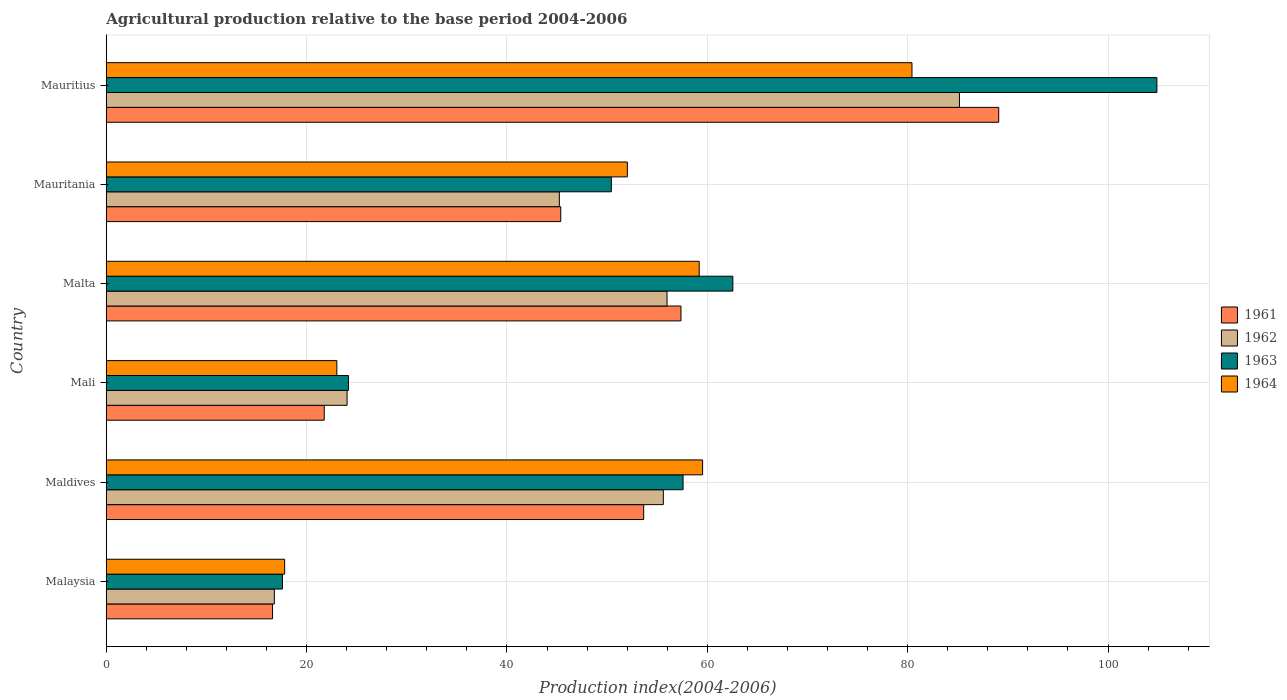How many different coloured bars are there?
Keep it short and to the point. 4. Are the number of bars per tick equal to the number of legend labels?
Provide a succinct answer. Yes. Are the number of bars on each tick of the Y-axis equal?
Your answer should be compact. Yes. What is the label of the 5th group of bars from the top?
Offer a terse response. Maldives. Across all countries, what is the maximum agricultural production index in 1961?
Offer a terse response. 89.09. In which country was the agricultural production index in 1964 maximum?
Your response must be concise. Mauritius. In which country was the agricultural production index in 1961 minimum?
Give a very brief answer. Malaysia. What is the total agricultural production index in 1962 in the graph?
Give a very brief answer. 282.81. What is the difference between the agricultural production index in 1962 in Maldives and that in Malta?
Your answer should be very brief. -0.37. What is the difference between the agricultural production index in 1962 in Maldives and the agricultural production index in 1963 in Mali?
Offer a terse response. 31.43. What is the average agricultural production index in 1963 per country?
Offer a very short reply. 52.87. What is the difference between the agricultural production index in 1961 and agricultural production index in 1964 in Mauritania?
Your answer should be compact. -6.65. What is the ratio of the agricultural production index in 1961 in Malaysia to that in Mauritania?
Make the answer very short. 0.37. Is the agricultural production index in 1964 in Mali less than that in Mauritius?
Offer a terse response. Yes. What is the difference between the highest and the second highest agricultural production index in 1962?
Keep it short and to the point. 29.19. What is the difference between the highest and the lowest agricultural production index in 1962?
Offer a very short reply. 68.39. What does the 1st bar from the top in Mauritius represents?
Offer a very short reply. 1964. What does the 2nd bar from the bottom in Malta represents?
Make the answer very short. 1962. How many countries are there in the graph?
Offer a very short reply. 6. What is the difference between two consecutive major ticks on the X-axis?
Keep it short and to the point. 20. Are the values on the major ticks of X-axis written in scientific E-notation?
Keep it short and to the point. No. Does the graph contain any zero values?
Your answer should be compact. No. Where does the legend appear in the graph?
Offer a very short reply. Center right. How many legend labels are there?
Your answer should be compact. 4. How are the legend labels stacked?
Provide a succinct answer. Vertical. What is the title of the graph?
Provide a short and direct response. Agricultural production relative to the base period 2004-2006. Does "1998" appear as one of the legend labels in the graph?
Keep it short and to the point. No. What is the label or title of the X-axis?
Your response must be concise. Production index(2004-2006). What is the label or title of the Y-axis?
Ensure brevity in your answer.  Country. What is the Production index(2004-2006) in 1961 in Malaysia?
Give a very brief answer. 16.6. What is the Production index(2004-2006) in 1962 in Malaysia?
Offer a very short reply. 16.78. What is the Production index(2004-2006) of 1963 in Malaysia?
Provide a succinct answer. 17.59. What is the Production index(2004-2006) of 1964 in Malaysia?
Provide a succinct answer. 17.81. What is the Production index(2004-2006) of 1961 in Maldives?
Your response must be concise. 53.65. What is the Production index(2004-2006) of 1962 in Maldives?
Ensure brevity in your answer.  55.61. What is the Production index(2004-2006) of 1963 in Maldives?
Give a very brief answer. 57.58. What is the Production index(2004-2006) of 1964 in Maldives?
Ensure brevity in your answer.  59.53. What is the Production index(2004-2006) of 1961 in Mali?
Offer a terse response. 21.76. What is the Production index(2004-2006) of 1962 in Mali?
Ensure brevity in your answer.  24.04. What is the Production index(2004-2006) in 1963 in Mali?
Provide a short and direct response. 24.18. What is the Production index(2004-2006) of 1964 in Mali?
Give a very brief answer. 23.02. What is the Production index(2004-2006) of 1961 in Malta?
Your response must be concise. 57.37. What is the Production index(2004-2006) of 1962 in Malta?
Your answer should be compact. 55.98. What is the Production index(2004-2006) in 1963 in Malta?
Provide a succinct answer. 62.55. What is the Production index(2004-2006) of 1964 in Malta?
Provide a short and direct response. 59.19. What is the Production index(2004-2006) of 1961 in Mauritania?
Your answer should be compact. 45.37. What is the Production index(2004-2006) in 1962 in Mauritania?
Make the answer very short. 45.23. What is the Production index(2004-2006) in 1963 in Mauritania?
Offer a terse response. 50.42. What is the Production index(2004-2006) in 1964 in Mauritania?
Your answer should be compact. 52.02. What is the Production index(2004-2006) in 1961 in Mauritius?
Your response must be concise. 89.09. What is the Production index(2004-2006) of 1962 in Mauritius?
Provide a succinct answer. 85.17. What is the Production index(2004-2006) in 1963 in Mauritius?
Offer a very short reply. 104.88. What is the Production index(2004-2006) in 1964 in Mauritius?
Provide a short and direct response. 80.43. Across all countries, what is the maximum Production index(2004-2006) in 1961?
Provide a short and direct response. 89.09. Across all countries, what is the maximum Production index(2004-2006) in 1962?
Ensure brevity in your answer.  85.17. Across all countries, what is the maximum Production index(2004-2006) of 1963?
Offer a terse response. 104.88. Across all countries, what is the maximum Production index(2004-2006) of 1964?
Your answer should be very brief. 80.43. Across all countries, what is the minimum Production index(2004-2006) of 1961?
Your answer should be very brief. 16.6. Across all countries, what is the minimum Production index(2004-2006) in 1962?
Provide a short and direct response. 16.78. Across all countries, what is the minimum Production index(2004-2006) in 1963?
Make the answer very short. 17.59. Across all countries, what is the minimum Production index(2004-2006) in 1964?
Your answer should be very brief. 17.81. What is the total Production index(2004-2006) in 1961 in the graph?
Provide a succinct answer. 283.84. What is the total Production index(2004-2006) of 1962 in the graph?
Keep it short and to the point. 282.81. What is the total Production index(2004-2006) of 1963 in the graph?
Keep it short and to the point. 317.2. What is the total Production index(2004-2006) in 1964 in the graph?
Provide a succinct answer. 292. What is the difference between the Production index(2004-2006) of 1961 in Malaysia and that in Maldives?
Make the answer very short. -37.05. What is the difference between the Production index(2004-2006) in 1962 in Malaysia and that in Maldives?
Ensure brevity in your answer.  -38.83. What is the difference between the Production index(2004-2006) in 1963 in Malaysia and that in Maldives?
Provide a short and direct response. -39.99. What is the difference between the Production index(2004-2006) of 1964 in Malaysia and that in Maldives?
Offer a terse response. -41.72. What is the difference between the Production index(2004-2006) of 1961 in Malaysia and that in Mali?
Provide a short and direct response. -5.16. What is the difference between the Production index(2004-2006) in 1962 in Malaysia and that in Mali?
Give a very brief answer. -7.26. What is the difference between the Production index(2004-2006) of 1963 in Malaysia and that in Mali?
Your response must be concise. -6.59. What is the difference between the Production index(2004-2006) in 1964 in Malaysia and that in Mali?
Your response must be concise. -5.21. What is the difference between the Production index(2004-2006) of 1961 in Malaysia and that in Malta?
Ensure brevity in your answer.  -40.77. What is the difference between the Production index(2004-2006) in 1962 in Malaysia and that in Malta?
Provide a succinct answer. -39.2. What is the difference between the Production index(2004-2006) of 1963 in Malaysia and that in Malta?
Make the answer very short. -44.96. What is the difference between the Production index(2004-2006) of 1964 in Malaysia and that in Malta?
Make the answer very short. -41.38. What is the difference between the Production index(2004-2006) in 1961 in Malaysia and that in Mauritania?
Provide a succinct answer. -28.77. What is the difference between the Production index(2004-2006) of 1962 in Malaysia and that in Mauritania?
Give a very brief answer. -28.45. What is the difference between the Production index(2004-2006) in 1963 in Malaysia and that in Mauritania?
Give a very brief answer. -32.83. What is the difference between the Production index(2004-2006) of 1964 in Malaysia and that in Mauritania?
Make the answer very short. -34.21. What is the difference between the Production index(2004-2006) in 1961 in Malaysia and that in Mauritius?
Offer a terse response. -72.49. What is the difference between the Production index(2004-2006) of 1962 in Malaysia and that in Mauritius?
Ensure brevity in your answer.  -68.39. What is the difference between the Production index(2004-2006) of 1963 in Malaysia and that in Mauritius?
Your answer should be very brief. -87.29. What is the difference between the Production index(2004-2006) in 1964 in Malaysia and that in Mauritius?
Provide a succinct answer. -62.62. What is the difference between the Production index(2004-2006) in 1961 in Maldives and that in Mali?
Ensure brevity in your answer.  31.89. What is the difference between the Production index(2004-2006) in 1962 in Maldives and that in Mali?
Offer a very short reply. 31.57. What is the difference between the Production index(2004-2006) of 1963 in Maldives and that in Mali?
Your answer should be very brief. 33.4. What is the difference between the Production index(2004-2006) of 1964 in Maldives and that in Mali?
Your response must be concise. 36.51. What is the difference between the Production index(2004-2006) in 1961 in Maldives and that in Malta?
Make the answer very short. -3.72. What is the difference between the Production index(2004-2006) in 1962 in Maldives and that in Malta?
Your response must be concise. -0.37. What is the difference between the Production index(2004-2006) in 1963 in Maldives and that in Malta?
Your response must be concise. -4.97. What is the difference between the Production index(2004-2006) of 1964 in Maldives and that in Malta?
Your answer should be compact. 0.34. What is the difference between the Production index(2004-2006) of 1961 in Maldives and that in Mauritania?
Keep it short and to the point. 8.28. What is the difference between the Production index(2004-2006) in 1962 in Maldives and that in Mauritania?
Give a very brief answer. 10.38. What is the difference between the Production index(2004-2006) in 1963 in Maldives and that in Mauritania?
Keep it short and to the point. 7.16. What is the difference between the Production index(2004-2006) in 1964 in Maldives and that in Mauritania?
Your answer should be compact. 7.51. What is the difference between the Production index(2004-2006) of 1961 in Maldives and that in Mauritius?
Provide a succinct answer. -35.44. What is the difference between the Production index(2004-2006) in 1962 in Maldives and that in Mauritius?
Make the answer very short. -29.56. What is the difference between the Production index(2004-2006) of 1963 in Maldives and that in Mauritius?
Give a very brief answer. -47.3. What is the difference between the Production index(2004-2006) of 1964 in Maldives and that in Mauritius?
Ensure brevity in your answer.  -20.9. What is the difference between the Production index(2004-2006) in 1961 in Mali and that in Malta?
Provide a succinct answer. -35.61. What is the difference between the Production index(2004-2006) of 1962 in Mali and that in Malta?
Offer a very short reply. -31.94. What is the difference between the Production index(2004-2006) in 1963 in Mali and that in Malta?
Your response must be concise. -38.37. What is the difference between the Production index(2004-2006) in 1964 in Mali and that in Malta?
Offer a very short reply. -36.17. What is the difference between the Production index(2004-2006) of 1961 in Mali and that in Mauritania?
Your response must be concise. -23.61. What is the difference between the Production index(2004-2006) of 1962 in Mali and that in Mauritania?
Offer a terse response. -21.19. What is the difference between the Production index(2004-2006) of 1963 in Mali and that in Mauritania?
Offer a terse response. -26.24. What is the difference between the Production index(2004-2006) of 1961 in Mali and that in Mauritius?
Ensure brevity in your answer.  -67.33. What is the difference between the Production index(2004-2006) in 1962 in Mali and that in Mauritius?
Provide a short and direct response. -61.13. What is the difference between the Production index(2004-2006) in 1963 in Mali and that in Mauritius?
Your response must be concise. -80.7. What is the difference between the Production index(2004-2006) in 1964 in Mali and that in Mauritius?
Your answer should be very brief. -57.41. What is the difference between the Production index(2004-2006) of 1962 in Malta and that in Mauritania?
Offer a very short reply. 10.75. What is the difference between the Production index(2004-2006) of 1963 in Malta and that in Mauritania?
Your answer should be very brief. 12.13. What is the difference between the Production index(2004-2006) in 1964 in Malta and that in Mauritania?
Offer a very short reply. 7.17. What is the difference between the Production index(2004-2006) of 1961 in Malta and that in Mauritius?
Your answer should be very brief. -31.72. What is the difference between the Production index(2004-2006) in 1962 in Malta and that in Mauritius?
Your response must be concise. -29.19. What is the difference between the Production index(2004-2006) in 1963 in Malta and that in Mauritius?
Your response must be concise. -42.33. What is the difference between the Production index(2004-2006) in 1964 in Malta and that in Mauritius?
Provide a succinct answer. -21.24. What is the difference between the Production index(2004-2006) of 1961 in Mauritania and that in Mauritius?
Your response must be concise. -43.72. What is the difference between the Production index(2004-2006) of 1962 in Mauritania and that in Mauritius?
Offer a terse response. -39.94. What is the difference between the Production index(2004-2006) in 1963 in Mauritania and that in Mauritius?
Your response must be concise. -54.46. What is the difference between the Production index(2004-2006) of 1964 in Mauritania and that in Mauritius?
Keep it short and to the point. -28.41. What is the difference between the Production index(2004-2006) of 1961 in Malaysia and the Production index(2004-2006) of 1962 in Maldives?
Provide a succinct answer. -39.01. What is the difference between the Production index(2004-2006) of 1961 in Malaysia and the Production index(2004-2006) of 1963 in Maldives?
Your answer should be compact. -40.98. What is the difference between the Production index(2004-2006) of 1961 in Malaysia and the Production index(2004-2006) of 1964 in Maldives?
Your answer should be very brief. -42.93. What is the difference between the Production index(2004-2006) in 1962 in Malaysia and the Production index(2004-2006) in 1963 in Maldives?
Keep it short and to the point. -40.8. What is the difference between the Production index(2004-2006) of 1962 in Malaysia and the Production index(2004-2006) of 1964 in Maldives?
Your response must be concise. -42.75. What is the difference between the Production index(2004-2006) in 1963 in Malaysia and the Production index(2004-2006) in 1964 in Maldives?
Keep it short and to the point. -41.94. What is the difference between the Production index(2004-2006) in 1961 in Malaysia and the Production index(2004-2006) in 1962 in Mali?
Your response must be concise. -7.44. What is the difference between the Production index(2004-2006) in 1961 in Malaysia and the Production index(2004-2006) in 1963 in Mali?
Ensure brevity in your answer.  -7.58. What is the difference between the Production index(2004-2006) of 1961 in Malaysia and the Production index(2004-2006) of 1964 in Mali?
Provide a short and direct response. -6.42. What is the difference between the Production index(2004-2006) of 1962 in Malaysia and the Production index(2004-2006) of 1963 in Mali?
Provide a succinct answer. -7.4. What is the difference between the Production index(2004-2006) of 1962 in Malaysia and the Production index(2004-2006) of 1964 in Mali?
Offer a very short reply. -6.24. What is the difference between the Production index(2004-2006) of 1963 in Malaysia and the Production index(2004-2006) of 1964 in Mali?
Offer a very short reply. -5.43. What is the difference between the Production index(2004-2006) of 1961 in Malaysia and the Production index(2004-2006) of 1962 in Malta?
Provide a short and direct response. -39.38. What is the difference between the Production index(2004-2006) in 1961 in Malaysia and the Production index(2004-2006) in 1963 in Malta?
Your answer should be compact. -45.95. What is the difference between the Production index(2004-2006) of 1961 in Malaysia and the Production index(2004-2006) of 1964 in Malta?
Offer a very short reply. -42.59. What is the difference between the Production index(2004-2006) in 1962 in Malaysia and the Production index(2004-2006) in 1963 in Malta?
Ensure brevity in your answer.  -45.77. What is the difference between the Production index(2004-2006) of 1962 in Malaysia and the Production index(2004-2006) of 1964 in Malta?
Offer a very short reply. -42.41. What is the difference between the Production index(2004-2006) in 1963 in Malaysia and the Production index(2004-2006) in 1964 in Malta?
Provide a short and direct response. -41.6. What is the difference between the Production index(2004-2006) in 1961 in Malaysia and the Production index(2004-2006) in 1962 in Mauritania?
Make the answer very short. -28.63. What is the difference between the Production index(2004-2006) of 1961 in Malaysia and the Production index(2004-2006) of 1963 in Mauritania?
Provide a succinct answer. -33.82. What is the difference between the Production index(2004-2006) in 1961 in Malaysia and the Production index(2004-2006) in 1964 in Mauritania?
Offer a terse response. -35.42. What is the difference between the Production index(2004-2006) in 1962 in Malaysia and the Production index(2004-2006) in 1963 in Mauritania?
Give a very brief answer. -33.64. What is the difference between the Production index(2004-2006) in 1962 in Malaysia and the Production index(2004-2006) in 1964 in Mauritania?
Your answer should be compact. -35.24. What is the difference between the Production index(2004-2006) of 1963 in Malaysia and the Production index(2004-2006) of 1964 in Mauritania?
Offer a terse response. -34.43. What is the difference between the Production index(2004-2006) in 1961 in Malaysia and the Production index(2004-2006) in 1962 in Mauritius?
Your answer should be compact. -68.57. What is the difference between the Production index(2004-2006) in 1961 in Malaysia and the Production index(2004-2006) in 1963 in Mauritius?
Your answer should be very brief. -88.28. What is the difference between the Production index(2004-2006) in 1961 in Malaysia and the Production index(2004-2006) in 1964 in Mauritius?
Ensure brevity in your answer.  -63.83. What is the difference between the Production index(2004-2006) of 1962 in Malaysia and the Production index(2004-2006) of 1963 in Mauritius?
Offer a terse response. -88.1. What is the difference between the Production index(2004-2006) of 1962 in Malaysia and the Production index(2004-2006) of 1964 in Mauritius?
Provide a short and direct response. -63.65. What is the difference between the Production index(2004-2006) of 1963 in Malaysia and the Production index(2004-2006) of 1964 in Mauritius?
Give a very brief answer. -62.84. What is the difference between the Production index(2004-2006) in 1961 in Maldives and the Production index(2004-2006) in 1962 in Mali?
Provide a succinct answer. 29.61. What is the difference between the Production index(2004-2006) of 1961 in Maldives and the Production index(2004-2006) of 1963 in Mali?
Provide a short and direct response. 29.47. What is the difference between the Production index(2004-2006) in 1961 in Maldives and the Production index(2004-2006) in 1964 in Mali?
Keep it short and to the point. 30.63. What is the difference between the Production index(2004-2006) in 1962 in Maldives and the Production index(2004-2006) in 1963 in Mali?
Provide a short and direct response. 31.43. What is the difference between the Production index(2004-2006) in 1962 in Maldives and the Production index(2004-2006) in 1964 in Mali?
Your response must be concise. 32.59. What is the difference between the Production index(2004-2006) in 1963 in Maldives and the Production index(2004-2006) in 1964 in Mali?
Ensure brevity in your answer.  34.56. What is the difference between the Production index(2004-2006) in 1961 in Maldives and the Production index(2004-2006) in 1962 in Malta?
Keep it short and to the point. -2.33. What is the difference between the Production index(2004-2006) in 1961 in Maldives and the Production index(2004-2006) in 1963 in Malta?
Make the answer very short. -8.9. What is the difference between the Production index(2004-2006) of 1961 in Maldives and the Production index(2004-2006) of 1964 in Malta?
Your answer should be compact. -5.54. What is the difference between the Production index(2004-2006) in 1962 in Maldives and the Production index(2004-2006) in 1963 in Malta?
Your response must be concise. -6.94. What is the difference between the Production index(2004-2006) of 1962 in Maldives and the Production index(2004-2006) of 1964 in Malta?
Give a very brief answer. -3.58. What is the difference between the Production index(2004-2006) of 1963 in Maldives and the Production index(2004-2006) of 1964 in Malta?
Make the answer very short. -1.61. What is the difference between the Production index(2004-2006) in 1961 in Maldives and the Production index(2004-2006) in 1962 in Mauritania?
Provide a succinct answer. 8.42. What is the difference between the Production index(2004-2006) in 1961 in Maldives and the Production index(2004-2006) in 1963 in Mauritania?
Offer a very short reply. 3.23. What is the difference between the Production index(2004-2006) in 1961 in Maldives and the Production index(2004-2006) in 1964 in Mauritania?
Give a very brief answer. 1.63. What is the difference between the Production index(2004-2006) in 1962 in Maldives and the Production index(2004-2006) in 1963 in Mauritania?
Make the answer very short. 5.19. What is the difference between the Production index(2004-2006) of 1962 in Maldives and the Production index(2004-2006) of 1964 in Mauritania?
Provide a short and direct response. 3.59. What is the difference between the Production index(2004-2006) in 1963 in Maldives and the Production index(2004-2006) in 1964 in Mauritania?
Offer a terse response. 5.56. What is the difference between the Production index(2004-2006) of 1961 in Maldives and the Production index(2004-2006) of 1962 in Mauritius?
Offer a very short reply. -31.52. What is the difference between the Production index(2004-2006) in 1961 in Maldives and the Production index(2004-2006) in 1963 in Mauritius?
Your response must be concise. -51.23. What is the difference between the Production index(2004-2006) in 1961 in Maldives and the Production index(2004-2006) in 1964 in Mauritius?
Your response must be concise. -26.78. What is the difference between the Production index(2004-2006) in 1962 in Maldives and the Production index(2004-2006) in 1963 in Mauritius?
Offer a very short reply. -49.27. What is the difference between the Production index(2004-2006) in 1962 in Maldives and the Production index(2004-2006) in 1964 in Mauritius?
Keep it short and to the point. -24.82. What is the difference between the Production index(2004-2006) of 1963 in Maldives and the Production index(2004-2006) of 1964 in Mauritius?
Your answer should be compact. -22.85. What is the difference between the Production index(2004-2006) in 1961 in Mali and the Production index(2004-2006) in 1962 in Malta?
Your answer should be very brief. -34.22. What is the difference between the Production index(2004-2006) of 1961 in Mali and the Production index(2004-2006) of 1963 in Malta?
Make the answer very short. -40.79. What is the difference between the Production index(2004-2006) of 1961 in Mali and the Production index(2004-2006) of 1964 in Malta?
Give a very brief answer. -37.43. What is the difference between the Production index(2004-2006) of 1962 in Mali and the Production index(2004-2006) of 1963 in Malta?
Offer a very short reply. -38.51. What is the difference between the Production index(2004-2006) of 1962 in Mali and the Production index(2004-2006) of 1964 in Malta?
Ensure brevity in your answer.  -35.15. What is the difference between the Production index(2004-2006) in 1963 in Mali and the Production index(2004-2006) in 1964 in Malta?
Make the answer very short. -35.01. What is the difference between the Production index(2004-2006) of 1961 in Mali and the Production index(2004-2006) of 1962 in Mauritania?
Offer a terse response. -23.47. What is the difference between the Production index(2004-2006) in 1961 in Mali and the Production index(2004-2006) in 1963 in Mauritania?
Offer a terse response. -28.66. What is the difference between the Production index(2004-2006) in 1961 in Mali and the Production index(2004-2006) in 1964 in Mauritania?
Provide a short and direct response. -30.26. What is the difference between the Production index(2004-2006) in 1962 in Mali and the Production index(2004-2006) in 1963 in Mauritania?
Offer a terse response. -26.38. What is the difference between the Production index(2004-2006) in 1962 in Mali and the Production index(2004-2006) in 1964 in Mauritania?
Offer a very short reply. -27.98. What is the difference between the Production index(2004-2006) of 1963 in Mali and the Production index(2004-2006) of 1964 in Mauritania?
Make the answer very short. -27.84. What is the difference between the Production index(2004-2006) of 1961 in Mali and the Production index(2004-2006) of 1962 in Mauritius?
Your answer should be compact. -63.41. What is the difference between the Production index(2004-2006) of 1961 in Mali and the Production index(2004-2006) of 1963 in Mauritius?
Your answer should be very brief. -83.12. What is the difference between the Production index(2004-2006) of 1961 in Mali and the Production index(2004-2006) of 1964 in Mauritius?
Offer a very short reply. -58.67. What is the difference between the Production index(2004-2006) of 1962 in Mali and the Production index(2004-2006) of 1963 in Mauritius?
Keep it short and to the point. -80.84. What is the difference between the Production index(2004-2006) in 1962 in Mali and the Production index(2004-2006) in 1964 in Mauritius?
Provide a succinct answer. -56.39. What is the difference between the Production index(2004-2006) of 1963 in Mali and the Production index(2004-2006) of 1964 in Mauritius?
Ensure brevity in your answer.  -56.25. What is the difference between the Production index(2004-2006) in 1961 in Malta and the Production index(2004-2006) in 1962 in Mauritania?
Offer a very short reply. 12.14. What is the difference between the Production index(2004-2006) of 1961 in Malta and the Production index(2004-2006) of 1963 in Mauritania?
Give a very brief answer. 6.95. What is the difference between the Production index(2004-2006) in 1961 in Malta and the Production index(2004-2006) in 1964 in Mauritania?
Offer a terse response. 5.35. What is the difference between the Production index(2004-2006) in 1962 in Malta and the Production index(2004-2006) in 1963 in Mauritania?
Your response must be concise. 5.56. What is the difference between the Production index(2004-2006) of 1962 in Malta and the Production index(2004-2006) of 1964 in Mauritania?
Give a very brief answer. 3.96. What is the difference between the Production index(2004-2006) of 1963 in Malta and the Production index(2004-2006) of 1964 in Mauritania?
Offer a very short reply. 10.53. What is the difference between the Production index(2004-2006) in 1961 in Malta and the Production index(2004-2006) in 1962 in Mauritius?
Provide a succinct answer. -27.8. What is the difference between the Production index(2004-2006) of 1961 in Malta and the Production index(2004-2006) of 1963 in Mauritius?
Offer a terse response. -47.51. What is the difference between the Production index(2004-2006) in 1961 in Malta and the Production index(2004-2006) in 1964 in Mauritius?
Your answer should be very brief. -23.06. What is the difference between the Production index(2004-2006) in 1962 in Malta and the Production index(2004-2006) in 1963 in Mauritius?
Offer a terse response. -48.9. What is the difference between the Production index(2004-2006) in 1962 in Malta and the Production index(2004-2006) in 1964 in Mauritius?
Give a very brief answer. -24.45. What is the difference between the Production index(2004-2006) in 1963 in Malta and the Production index(2004-2006) in 1964 in Mauritius?
Keep it short and to the point. -17.88. What is the difference between the Production index(2004-2006) of 1961 in Mauritania and the Production index(2004-2006) of 1962 in Mauritius?
Offer a terse response. -39.8. What is the difference between the Production index(2004-2006) in 1961 in Mauritania and the Production index(2004-2006) in 1963 in Mauritius?
Make the answer very short. -59.51. What is the difference between the Production index(2004-2006) in 1961 in Mauritania and the Production index(2004-2006) in 1964 in Mauritius?
Provide a succinct answer. -35.06. What is the difference between the Production index(2004-2006) in 1962 in Mauritania and the Production index(2004-2006) in 1963 in Mauritius?
Ensure brevity in your answer.  -59.65. What is the difference between the Production index(2004-2006) in 1962 in Mauritania and the Production index(2004-2006) in 1964 in Mauritius?
Offer a terse response. -35.2. What is the difference between the Production index(2004-2006) in 1963 in Mauritania and the Production index(2004-2006) in 1964 in Mauritius?
Your response must be concise. -30.01. What is the average Production index(2004-2006) of 1961 per country?
Give a very brief answer. 47.31. What is the average Production index(2004-2006) of 1962 per country?
Provide a short and direct response. 47.13. What is the average Production index(2004-2006) of 1963 per country?
Offer a terse response. 52.87. What is the average Production index(2004-2006) of 1964 per country?
Provide a succinct answer. 48.67. What is the difference between the Production index(2004-2006) in 1961 and Production index(2004-2006) in 1962 in Malaysia?
Your answer should be very brief. -0.18. What is the difference between the Production index(2004-2006) of 1961 and Production index(2004-2006) of 1963 in Malaysia?
Ensure brevity in your answer.  -0.99. What is the difference between the Production index(2004-2006) in 1961 and Production index(2004-2006) in 1964 in Malaysia?
Provide a succinct answer. -1.21. What is the difference between the Production index(2004-2006) of 1962 and Production index(2004-2006) of 1963 in Malaysia?
Ensure brevity in your answer.  -0.81. What is the difference between the Production index(2004-2006) of 1962 and Production index(2004-2006) of 1964 in Malaysia?
Offer a terse response. -1.03. What is the difference between the Production index(2004-2006) in 1963 and Production index(2004-2006) in 1964 in Malaysia?
Offer a very short reply. -0.22. What is the difference between the Production index(2004-2006) of 1961 and Production index(2004-2006) of 1962 in Maldives?
Give a very brief answer. -1.96. What is the difference between the Production index(2004-2006) in 1961 and Production index(2004-2006) in 1963 in Maldives?
Provide a short and direct response. -3.93. What is the difference between the Production index(2004-2006) in 1961 and Production index(2004-2006) in 1964 in Maldives?
Ensure brevity in your answer.  -5.88. What is the difference between the Production index(2004-2006) in 1962 and Production index(2004-2006) in 1963 in Maldives?
Make the answer very short. -1.97. What is the difference between the Production index(2004-2006) of 1962 and Production index(2004-2006) of 1964 in Maldives?
Your answer should be very brief. -3.92. What is the difference between the Production index(2004-2006) in 1963 and Production index(2004-2006) in 1964 in Maldives?
Provide a succinct answer. -1.95. What is the difference between the Production index(2004-2006) in 1961 and Production index(2004-2006) in 1962 in Mali?
Provide a succinct answer. -2.28. What is the difference between the Production index(2004-2006) in 1961 and Production index(2004-2006) in 1963 in Mali?
Make the answer very short. -2.42. What is the difference between the Production index(2004-2006) in 1961 and Production index(2004-2006) in 1964 in Mali?
Ensure brevity in your answer.  -1.26. What is the difference between the Production index(2004-2006) in 1962 and Production index(2004-2006) in 1963 in Mali?
Offer a terse response. -0.14. What is the difference between the Production index(2004-2006) in 1962 and Production index(2004-2006) in 1964 in Mali?
Your answer should be very brief. 1.02. What is the difference between the Production index(2004-2006) of 1963 and Production index(2004-2006) of 1964 in Mali?
Ensure brevity in your answer.  1.16. What is the difference between the Production index(2004-2006) in 1961 and Production index(2004-2006) in 1962 in Malta?
Offer a very short reply. 1.39. What is the difference between the Production index(2004-2006) in 1961 and Production index(2004-2006) in 1963 in Malta?
Provide a succinct answer. -5.18. What is the difference between the Production index(2004-2006) in 1961 and Production index(2004-2006) in 1964 in Malta?
Offer a very short reply. -1.82. What is the difference between the Production index(2004-2006) of 1962 and Production index(2004-2006) of 1963 in Malta?
Make the answer very short. -6.57. What is the difference between the Production index(2004-2006) of 1962 and Production index(2004-2006) of 1964 in Malta?
Give a very brief answer. -3.21. What is the difference between the Production index(2004-2006) in 1963 and Production index(2004-2006) in 1964 in Malta?
Give a very brief answer. 3.36. What is the difference between the Production index(2004-2006) in 1961 and Production index(2004-2006) in 1962 in Mauritania?
Your answer should be very brief. 0.14. What is the difference between the Production index(2004-2006) of 1961 and Production index(2004-2006) of 1963 in Mauritania?
Make the answer very short. -5.05. What is the difference between the Production index(2004-2006) of 1961 and Production index(2004-2006) of 1964 in Mauritania?
Your answer should be compact. -6.65. What is the difference between the Production index(2004-2006) of 1962 and Production index(2004-2006) of 1963 in Mauritania?
Give a very brief answer. -5.19. What is the difference between the Production index(2004-2006) of 1962 and Production index(2004-2006) of 1964 in Mauritania?
Ensure brevity in your answer.  -6.79. What is the difference between the Production index(2004-2006) in 1963 and Production index(2004-2006) in 1964 in Mauritania?
Offer a terse response. -1.6. What is the difference between the Production index(2004-2006) of 1961 and Production index(2004-2006) of 1962 in Mauritius?
Your answer should be very brief. 3.92. What is the difference between the Production index(2004-2006) in 1961 and Production index(2004-2006) in 1963 in Mauritius?
Make the answer very short. -15.79. What is the difference between the Production index(2004-2006) in 1961 and Production index(2004-2006) in 1964 in Mauritius?
Offer a terse response. 8.66. What is the difference between the Production index(2004-2006) of 1962 and Production index(2004-2006) of 1963 in Mauritius?
Your answer should be compact. -19.71. What is the difference between the Production index(2004-2006) of 1962 and Production index(2004-2006) of 1964 in Mauritius?
Give a very brief answer. 4.74. What is the difference between the Production index(2004-2006) of 1963 and Production index(2004-2006) of 1964 in Mauritius?
Keep it short and to the point. 24.45. What is the ratio of the Production index(2004-2006) in 1961 in Malaysia to that in Maldives?
Keep it short and to the point. 0.31. What is the ratio of the Production index(2004-2006) of 1962 in Malaysia to that in Maldives?
Keep it short and to the point. 0.3. What is the ratio of the Production index(2004-2006) in 1963 in Malaysia to that in Maldives?
Provide a short and direct response. 0.31. What is the ratio of the Production index(2004-2006) of 1964 in Malaysia to that in Maldives?
Offer a terse response. 0.3. What is the ratio of the Production index(2004-2006) of 1961 in Malaysia to that in Mali?
Ensure brevity in your answer.  0.76. What is the ratio of the Production index(2004-2006) in 1962 in Malaysia to that in Mali?
Keep it short and to the point. 0.7. What is the ratio of the Production index(2004-2006) of 1963 in Malaysia to that in Mali?
Your response must be concise. 0.73. What is the ratio of the Production index(2004-2006) of 1964 in Malaysia to that in Mali?
Ensure brevity in your answer.  0.77. What is the ratio of the Production index(2004-2006) in 1961 in Malaysia to that in Malta?
Your answer should be very brief. 0.29. What is the ratio of the Production index(2004-2006) in 1962 in Malaysia to that in Malta?
Your response must be concise. 0.3. What is the ratio of the Production index(2004-2006) in 1963 in Malaysia to that in Malta?
Offer a terse response. 0.28. What is the ratio of the Production index(2004-2006) in 1964 in Malaysia to that in Malta?
Make the answer very short. 0.3. What is the ratio of the Production index(2004-2006) of 1961 in Malaysia to that in Mauritania?
Provide a succinct answer. 0.37. What is the ratio of the Production index(2004-2006) in 1962 in Malaysia to that in Mauritania?
Make the answer very short. 0.37. What is the ratio of the Production index(2004-2006) of 1963 in Malaysia to that in Mauritania?
Your response must be concise. 0.35. What is the ratio of the Production index(2004-2006) of 1964 in Malaysia to that in Mauritania?
Your answer should be compact. 0.34. What is the ratio of the Production index(2004-2006) of 1961 in Malaysia to that in Mauritius?
Make the answer very short. 0.19. What is the ratio of the Production index(2004-2006) in 1962 in Malaysia to that in Mauritius?
Ensure brevity in your answer.  0.2. What is the ratio of the Production index(2004-2006) in 1963 in Malaysia to that in Mauritius?
Offer a terse response. 0.17. What is the ratio of the Production index(2004-2006) of 1964 in Malaysia to that in Mauritius?
Offer a terse response. 0.22. What is the ratio of the Production index(2004-2006) of 1961 in Maldives to that in Mali?
Keep it short and to the point. 2.47. What is the ratio of the Production index(2004-2006) of 1962 in Maldives to that in Mali?
Provide a succinct answer. 2.31. What is the ratio of the Production index(2004-2006) of 1963 in Maldives to that in Mali?
Your answer should be compact. 2.38. What is the ratio of the Production index(2004-2006) in 1964 in Maldives to that in Mali?
Keep it short and to the point. 2.59. What is the ratio of the Production index(2004-2006) of 1961 in Maldives to that in Malta?
Offer a very short reply. 0.94. What is the ratio of the Production index(2004-2006) of 1962 in Maldives to that in Malta?
Give a very brief answer. 0.99. What is the ratio of the Production index(2004-2006) of 1963 in Maldives to that in Malta?
Your answer should be compact. 0.92. What is the ratio of the Production index(2004-2006) of 1961 in Maldives to that in Mauritania?
Offer a terse response. 1.18. What is the ratio of the Production index(2004-2006) in 1962 in Maldives to that in Mauritania?
Offer a terse response. 1.23. What is the ratio of the Production index(2004-2006) of 1963 in Maldives to that in Mauritania?
Keep it short and to the point. 1.14. What is the ratio of the Production index(2004-2006) in 1964 in Maldives to that in Mauritania?
Provide a short and direct response. 1.14. What is the ratio of the Production index(2004-2006) of 1961 in Maldives to that in Mauritius?
Give a very brief answer. 0.6. What is the ratio of the Production index(2004-2006) of 1962 in Maldives to that in Mauritius?
Give a very brief answer. 0.65. What is the ratio of the Production index(2004-2006) in 1963 in Maldives to that in Mauritius?
Your answer should be very brief. 0.55. What is the ratio of the Production index(2004-2006) in 1964 in Maldives to that in Mauritius?
Your answer should be very brief. 0.74. What is the ratio of the Production index(2004-2006) of 1961 in Mali to that in Malta?
Offer a very short reply. 0.38. What is the ratio of the Production index(2004-2006) of 1962 in Mali to that in Malta?
Your answer should be very brief. 0.43. What is the ratio of the Production index(2004-2006) of 1963 in Mali to that in Malta?
Offer a terse response. 0.39. What is the ratio of the Production index(2004-2006) of 1964 in Mali to that in Malta?
Offer a terse response. 0.39. What is the ratio of the Production index(2004-2006) of 1961 in Mali to that in Mauritania?
Provide a succinct answer. 0.48. What is the ratio of the Production index(2004-2006) in 1962 in Mali to that in Mauritania?
Your response must be concise. 0.53. What is the ratio of the Production index(2004-2006) in 1963 in Mali to that in Mauritania?
Give a very brief answer. 0.48. What is the ratio of the Production index(2004-2006) in 1964 in Mali to that in Mauritania?
Give a very brief answer. 0.44. What is the ratio of the Production index(2004-2006) in 1961 in Mali to that in Mauritius?
Your response must be concise. 0.24. What is the ratio of the Production index(2004-2006) of 1962 in Mali to that in Mauritius?
Provide a short and direct response. 0.28. What is the ratio of the Production index(2004-2006) of 1963 in Mali to that in Mauritius?
Offer a very short reply. 0.23. What is the ratio of the Production index(2004-2006) in 1964 in Mali to that in Mauritius?
Your response must be concise. 0.29. What is the ratio of the Production index(2004-2006) of 1961 in Malta to that in Mauritania?
Give a very brief answer. 1.26. What is the ratio of the Production index(2004-2006) in 1962 in Malta to that in Mauritania?
Make the answer very short. 1.24. What is the ratio of the Production index(2004-2006) of 1963 in Malta to that in Mauritania?
Keep it short and to the point. 1.24. What is the ratio of the Production index(2004-2006) in 1964 in Malta to that in Mauritania?
Your answer should be very brief. 1.14. What is the ratio of the Production index(2004-2006) in 1961 in Malta to that in Mauritius?
Offer a very short reply. 0.64. What is the ratio of the Production index(2004-2006) in 1962 in Malta to that in Mauritius?
Your answer should be compact. 0.66. What is the ratio of the Production index(2004-2006) of 1963 in Malta to that in Mauritius?
Your response must be concise. 0.6. What is the ratio of the Production index(2004-2006) in 1964 in Malta to that in Mauritius?
Provide a succinct answer. 0.74. What is the ratio of the Production index(2004-2006) in 1961 in Mauritania to that in Mauritius?
Your answer should be compact. 0.51. What is the ratio of the Production index(2004-2006) in 1962 in Mauritania to that in Mauritius?
Keep it short and to the point. 0.53. What is the ratio of the Production index(2004-2006) of 1963 in Mauritania to that in Mauritius?
Offer a terse response. 0.48. What is the ratio of the Production index(2004-2006) of 1964 in Mauritania to that in Mauritius?
Keep it short and to the point. 0.65. What is the difference between the highest and the second highest Production index(2004-2006) of 1961?
Provide a succinct answer. 31.72. What is the difference between the highest and the second highest Production index(2004-2006) of 1962?
Give a very brief answer. 29.19. What is the difference between the highest and the second highest Production index(2004-2006) in 1963?
Offer a very short reply. 42.33. What is the difference between the highest and the second highest Production index(2004-2006) of 1964?
Keep it short and to the point. 20.9. What is the difference between the highest and the lowest Production index(2004-2006) of 1961?
Offer a very short reply. 72.49. What is the difference between the highest and the lowest Production index(2004-2006) in 1962?
Offer a terse response. 68.39. What is the difference between the highest and the lowest Production index(2004-2006) of 1963?
Make the answer very short. 87.29. What is the difference between the highest and the lowest Production index(2004-2006) of 1964?
Give a very brief answer. 62.62. 